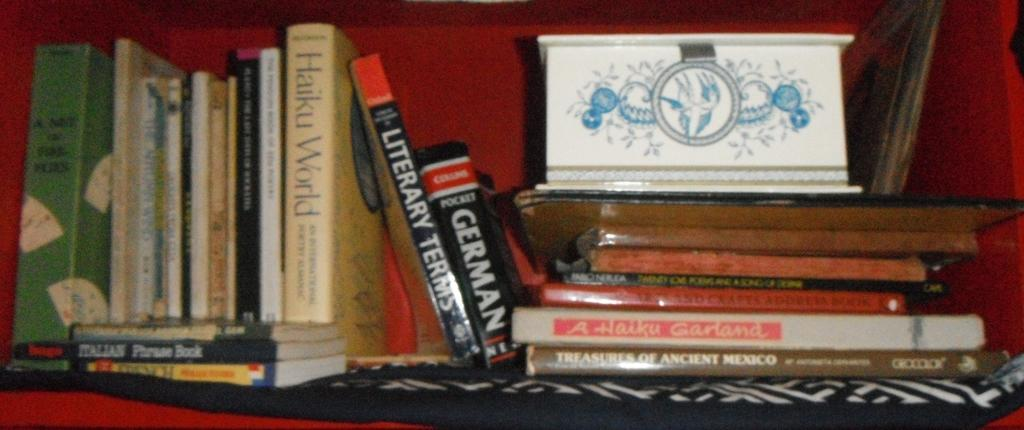What type of furniture is present in the image? There is a cabinet in the image. What can be found inside the cabinet? The cabinet contains a white color box and many books. Can you describe the books in the cabinet? The books have text written on their covers. What type of stocking is hanging from the cabinet in the image? There is no stocking hanging from the cabinet in the image. How does the grip of the cabinet appear in the image? The grip of the cabinet is not mentioned in the provided facts, so it cannot be determined from the image. 